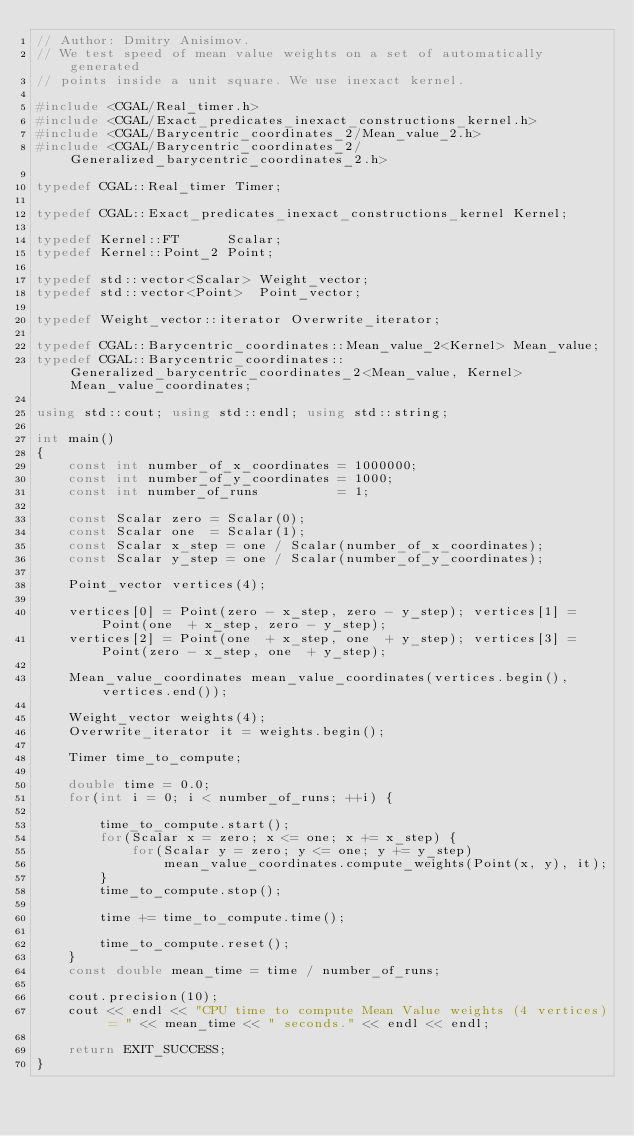<code> <loc_0><loc_0><loc_500><loc_500><_C++_>// Author: Dmitry Anisimov.
// We test speed of mean value weights on a set of automatically generated
// points inside a unit square. We use inexact kernel.

#include <CGAL/Real_timer.h>
#include <CGAL/Exact_predicates_inexact_constructions_kernel.h>
#include <CGAL/Barycentric_coordinates_2/Mean_value_2.h>
#include <CGAL/Barycentric_coordinates_2/Generalized_barycentric_coordinates_2.h>

typedef CGAL::Real_timer Timer;

typedef CGAL::Exact_predicates_inexact_constructions_kernel Kernel;

typedef Kernel::FT      Scalar;
typedef Kernel::Point_2 Point;

typedef std::vector<Scalar> Weight_vector;
typedef std::vector<Point>  Point_vector;

typedef Weight_vector::iterator Overwrite_iterator;

typedef CGAL::Barycentric_coordinates::Mean_value_2<Kernel> Mean_value;
typedef CGAL::Barycentric_coordinates::Generalized_barycentric_coordinates_2<Mean_value, Kernel> Mean_value_coordinates;

using std::cout; using std::endl; using std::string;

int main()
{
    const int number_of_x_coordinates = 1000000;
    const int number_of_y_coordinates = 1000;
    const int number_of_runs          = 1;

    const Scalar zero = Scalar(0);
    const Scalar one  = Scalar(1);
    const Scalar x_step = one / Scalar(number_of_x_coordinates);
    const Scalar y_step = one / Scalar(number_of_y_coordinates);

    Point_vector vertices(4);

    vertices[0] = Point(zero - x_step, zero - y_step); vertices[1] = Point(one  + x_step, zero - y_step);
    vertices[2] = Point(one  + x_step, one  + y_step); vertices[3] = Point(zero - x_step, one  + y_step);

    Mean_value_coordinates mean_value_coordinates(vertices.begin(), vertices.end());

    Weight_vector weights(4);
    Overwrite_iterator it = weights.begin();

    Timer time_to_compute;

    double time = 0.0;
    for(int i = 0; i < number_of_runs; ++i) {

        time_to_compute.start();
        for(Scalar x = zero; x <= one; x += x_step) {
            for(Scalar y = zero; y <= one; y += y_step)
                mean_value_coordinates.compute_weights(Point(x, y), it);
        }
        time_to_compute.stop();

        time += time_to_compute.time();

        time_to_compute.reset();
    }
    const double mean_time = time / number_of_runs;

    cout.precision(10);
    cout << endl << "CPU time to compute Mean Value weights (4 vertices) = " << mean_time << " seconds." << endl << endl;
    
    return EXIT_SUCCESS;
}
</code> 